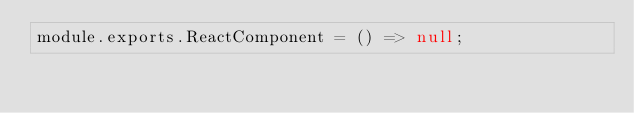Convert code to text. <code><loc_0><loc_0><loc_500><loc_500><_JavaScript_>module.exports.ReactComponent = () => null;
</code> 